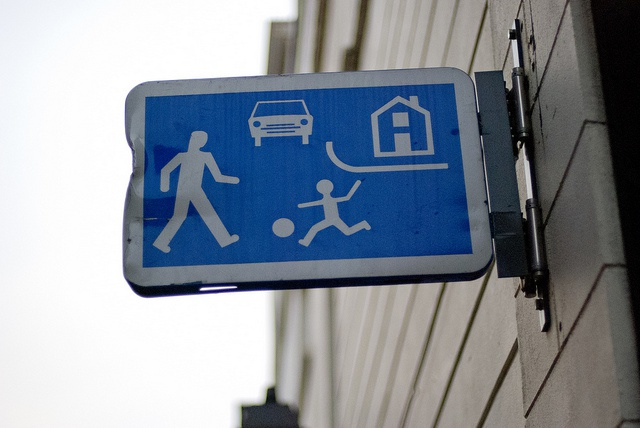Describe the objects in this image and their specific colors. I can see a sports ball in white, gray, and blue tones in this image. 